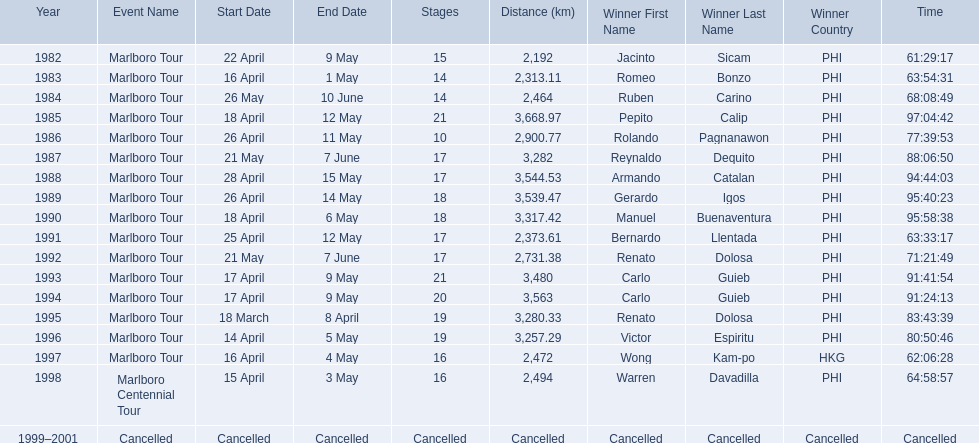Who were all of the winners? Jacinto Sicam (PHI), Romeo Bonzo (PHI), Ruben Carino (PHI), Pepito Calip (PHI), Rolando Pagnanawon (PHI), Reynaldo Dequito (PHI), Armando Catalan (PHI), Gerardo Igos (PHI), Manuel Buenaventura (PHI), Bernardo Llentada (PHI), Renato Dolosa (PHI), Carlo Guieb (PHI), Carlo Guieb (PHI), Renato Dolosa (PHI), Victor Espiritu (PHI), Wong Kam-po (HKG), Warren Davadilla (PHI), Cancelled. When did they compete? 1982, 1983, 1984, 1985, 1986, 1987, 1988, 1989, 1990, 1991, 1992, 1993, 1994, 1995, 1996, 1997, 1998, 1999–2001. What were their finishing times? 61:29:17, 63:54:31, 68:08:49, 97:04:42, 77:39:53, 88:06:50, 94:44:03, 95:40:23, 95:58:38, 63:33:17, 71:21:49, 91:41:54, 91:24:13, 83:43:39, 80:50:46, 62:06:28, 64:58:57, Cancelled. And who won during 1998? Warren Davadilla (PHI). What was his time? 64:58:57. 